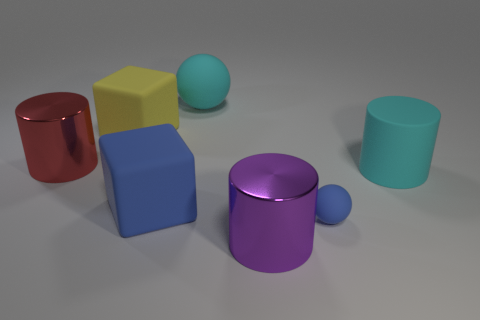Subtract all shiny cylinders. How many cylinders are left? 1 Add 2 big blocks. How many objects exist? 9 Subtract all cylinders. How many objects are left? 4 Subtract all gray cylinders. Subtract all yellow balls. How many cylinders are left? 3 Subtract all metallic objects. Subtract all cyan cylinders. How many objects are left? 4 Add 2 big red shiny cylinders. How many big red shiny cylinders are left? 3 Add 4 rubber balls. How many rubber balls exist? 6 Subtract 0 brown spheres. How many objects are left? 7 